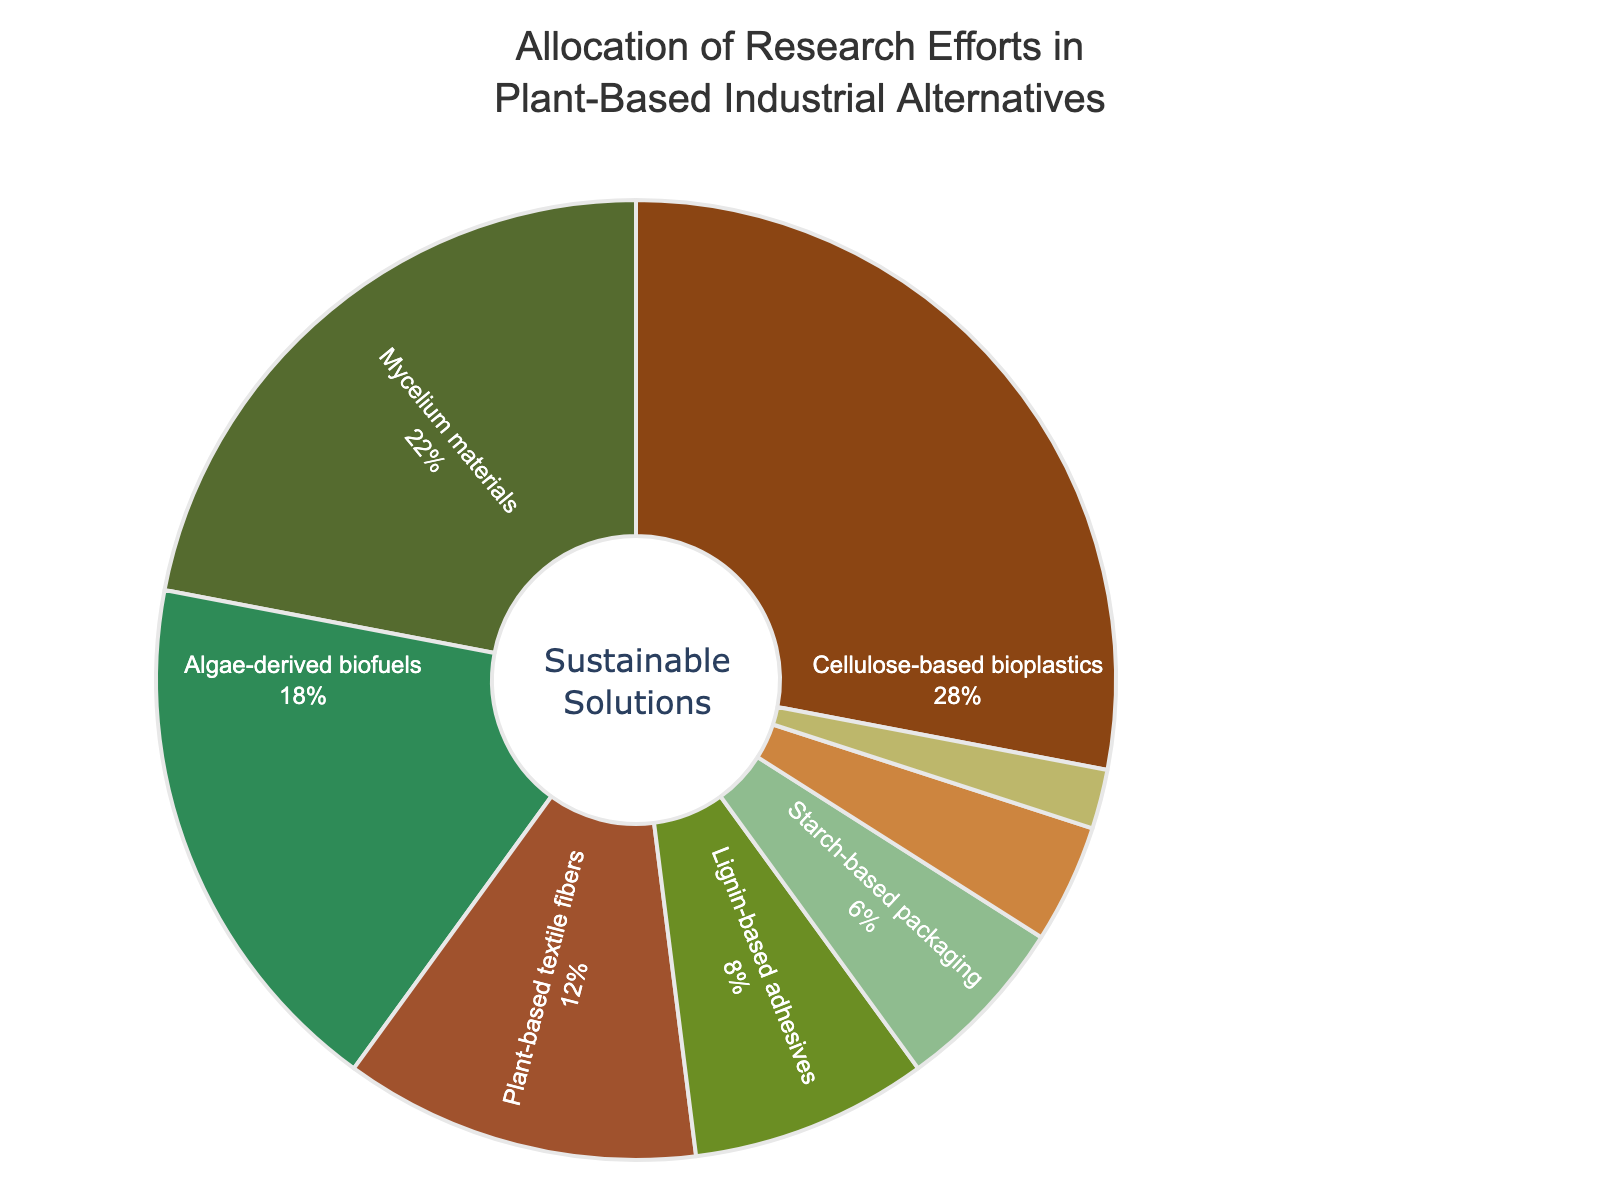What category receives the highest proportion of research efforts? By observing the size of the slices in the pie chart, the largest slice directly corresponds to the category with the highest research allocation.
Answer: Cellulose-based bioplastics Which two categories combined account for more than 50% of research efforts? Add the percentages of the largest categories until the sum exceeds 50%. Cellulose-based bioplastics (28%) and Mycelium materials (22%) together sum to 50%, which is not over 50%, so we must include the next highest, making the first two categories that exceed 50%: Cellulose-based bioplastics (28%) and Mycelium materials (22%) which sum exactly to 50%.
Answer: Cellulose-based bioplastics and Mycelium materials What is the difference in research allocation between Algae-derived biofuels and Plant-based textile fibers? Subtract the percentage of Plant-based textile fibers (12%) from the percentage of Algae-derived biofuels (18%).
Answer: 6% Which category receives double the research efforts compared to Starch-based packaging? Identify the percentage of Starch-based packaging (6%) and find the category with double this percentage. The category with 12% is Plant-based textile fibers, which is double 6%.
Answer: Plant-based textile fibers List the categories that receive less than 10% of research efforts. Simply identify the slices with percentages below 10%: Lignin-based adhesives (8%), Starch-based packaging (6%), Fruit waste biocomposites (4%), Bamboo construction materials (2%).
Answer: Lignin-based adhesives, Starch-based packaging, Fruit waste biocomposites, Bamboo construction materials How much more research effort is allocated to Mycelium materials compared to Fruit waste biocomposites? Subtract the percentage of Fruit waste biocomposites (4%) from the percentage of Mycelium materials (22%).
Answer: 18% What category has the smallest allocation and what is its percentage? Identify the smallest slice in the pie chart, which corresponds to Bamboo construction materials, and note its percentage (2%).
Answer: Bamboo construction materials, 2% By how much does the allocation for Cellulose-based bioplastics exceed the allocation for Lignin-based adhesives? Subtract the percentage of Lignin-based adhesives (8%) from the percentage of Cellulose-based bioplastics (28%).
Answer: 20% Do the research efforts allocated to Algae-derived biofuels and Bamboo construction materials together exceed those allocated to Mycelium materials? Add the percentages of Algae-derived biofuels and Bamboo construction materials (18% + 2% = 20%) and compare it to Mycelium materials (22%). Since 20% is less than 22%, the combined efforts do not exceed Mycelium materials' allocation.
Answer: No 